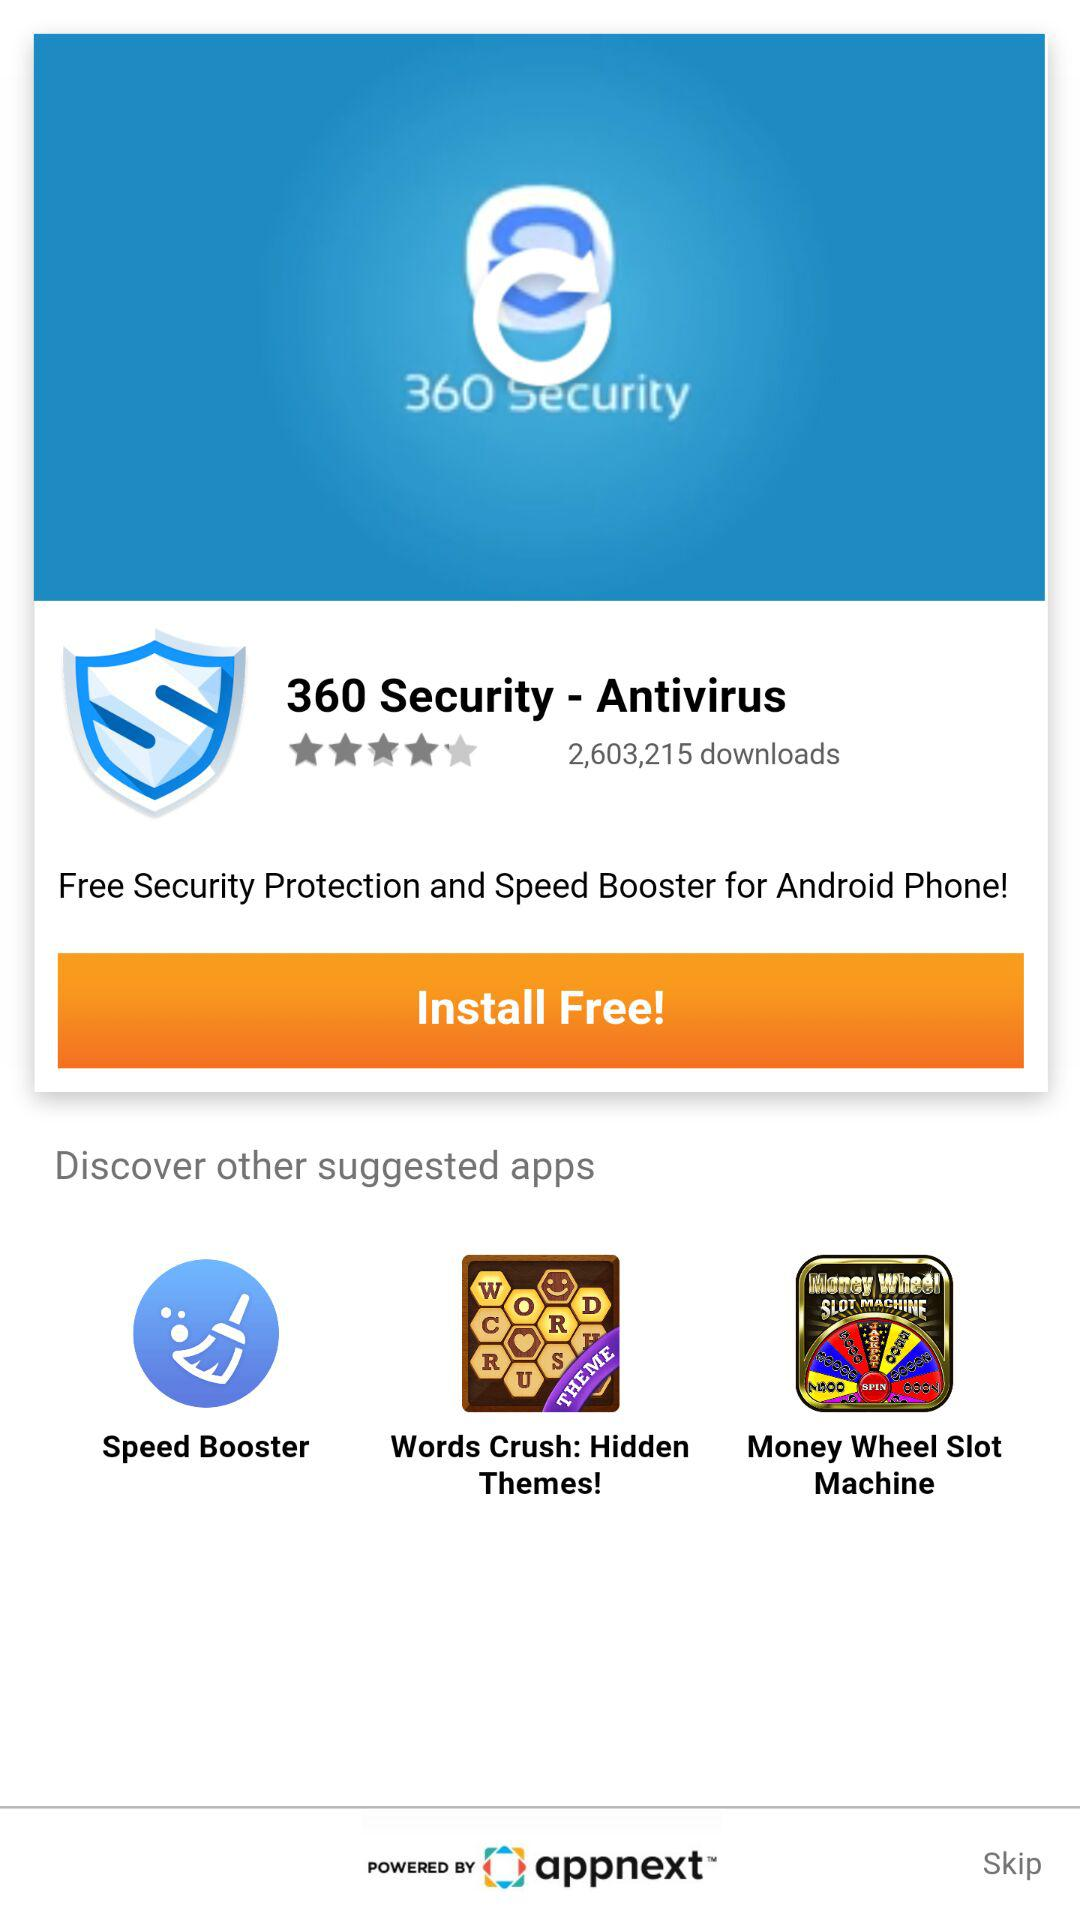Is app free or paid?
When the provided information is insufficient, respond with <no answer>. <no answer> 